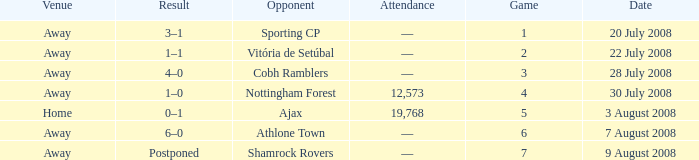What is the venue of game 3? Away. 